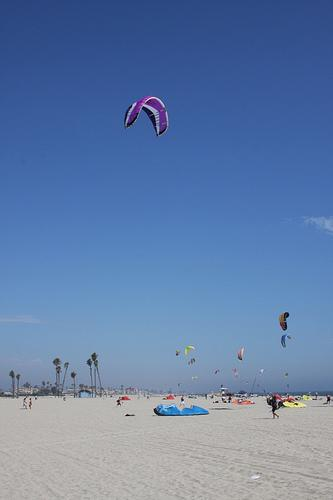What type of weather is the beach seeing today? sunny 